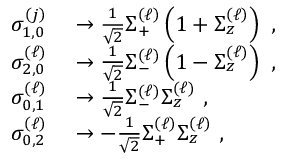<formula> <loc_0><loc_0><loc_500><loc_500>\begin{array} { r l } { \sigma _ { 1 , 0 } ^ { \left ( j \right ) } } & \rightarrow \frac { 1 } { \sqrt { 2 } } \Sigma _ { + } ^ { \left ( \ell \right ) } \left ( 1 + \Sigma _ { z } ^ { \left ( \ell \right ) } \right ) \, , } \\ { \sigma _ { 2 , 0 } ^ { \left ( \ell \right ) } } & \rightarrow \frac { 1 } { \sqrt { 2 } } \Sigma _ { - } ^ { \left ( \ell \right ) } \left ( 1 - \Sigma _ { z } ^ { \left ( \ell \right ) } \right ) \, , } \\ { \sigma _ { 0 , 1 } ^ { \left ( \ell \right ) } } & \rightarrow \frac { 1 } { \sqrt { 2 } } \Sigma _ { - } ^ { \left ( \ell \right ) } \Sigma _ { z } ^ { \left ( \ell \right ) } \, , } \\ { \sigma _ { 0 , 2 } ^ { \left ( \ell \right ) } } & \rightarrow - \frac { 1 } { \sqrt { 2 } } \Sigma _ { + } ^ { \left ( \ell \right ) } \Sigma _ { z } ^ { \left ( \ell \right ) } \, , } \end{array}</formula> 